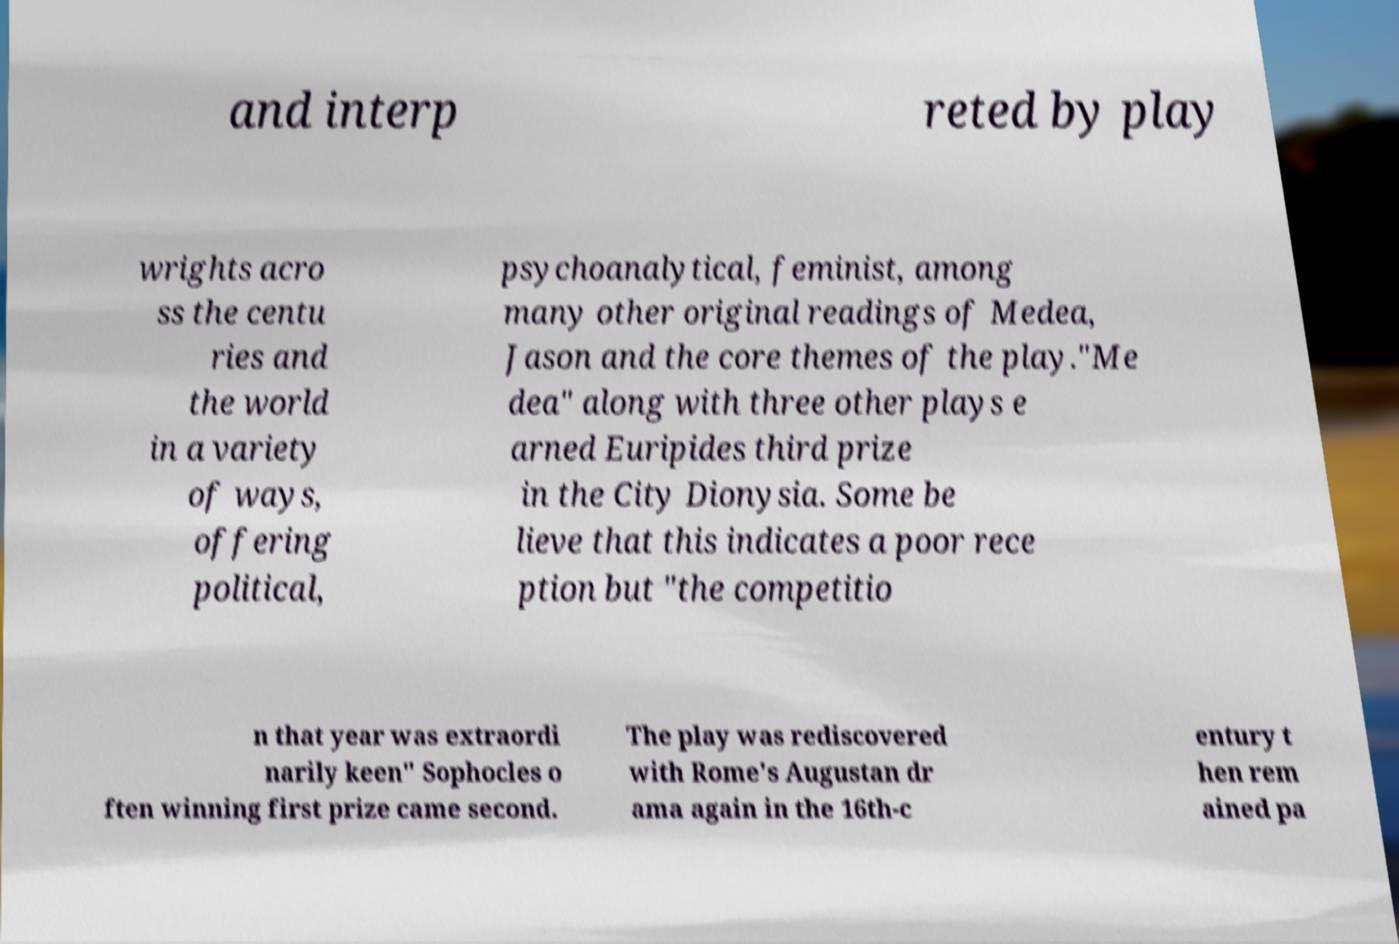For documentation purposes, I need the text within this image transcribed. Could you provide that? and interp reted by play wrights acro ss the centu ries and the world in a variety of ways, offering political, psychoanalytical, feminist, among many other original readings of Medea, Jason and the core themes of the play."Me dea" along with three other plays e arned Euripides third prize in the City Dionysia. Some be lieve that this indicates a poor rece ption but "the competitio n that year was extraordi narily keen" Sophocles o ften winning first prize came second. The play was rediscovered with Rome's Augustan dr ama again in the 16th-c entury t hen rem ained pa 